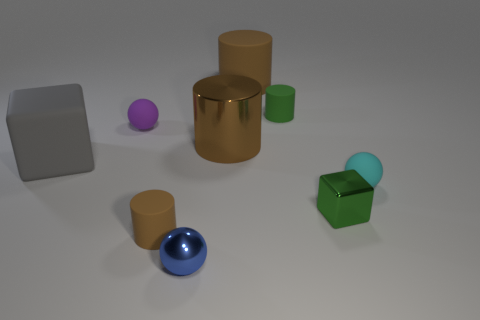There is another matte cylinder that is the same color as the large matte cylinder; what is its size?
Give a very brief answer. Small. There is a small ball that is behind the block that is on the left side of the brown thing that is to the left of the blue metallic thing; what is its color?
Offer a very short reply. Purple. The rubber thing that is in front of the big metal cylinder and on the right side of the tiny blue sphere has what shape?
Keep it short and to the point. Sphere. What number of other things are the same shape as the purple thing?
Keep it short and to the point. 2. There is a brown object that is behind the small green thing that is behind the tiny green object that is in front of the gray thing; what shape is it?
Ensure brevity in your answer.  Cylinder. What number of objects are small red things or rubber things that are to the right of the brown metal cylinder?
Make the answer very short. 3. There is a large thing left of the metallic cylinder; does it have the same shape as the green object that is behind the gray matte object?
Make the answer very short. No. What number of things are either cyan things or purple objects?
Give a very brief answer. 2. Is there any other thing that has the same material as the gray block?
Ensure brevity in your answer.  Yes. Are any green matte spheres visible?
Provide a short and direct response. No. 